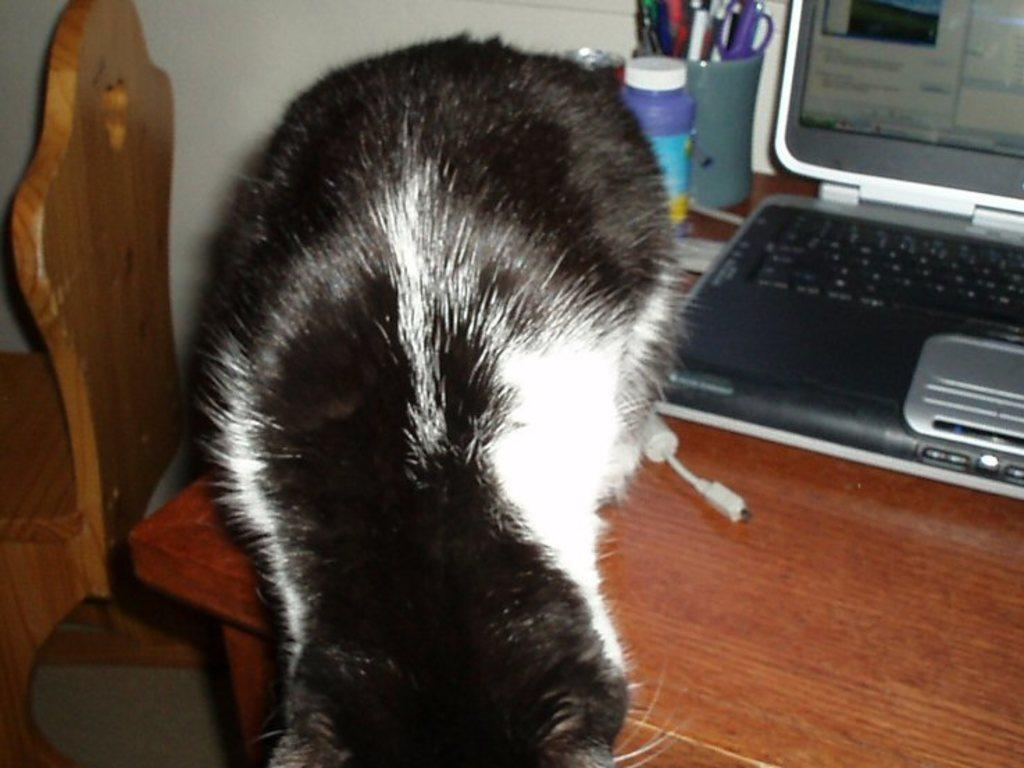What piece of furniture is present in the image? There is a chair in the image. What electronic device is on the table in the image? There is a laptop on a table in the image. What type of animal is on the table in the image? There is a cat on the table in the image. What type of container is in the image? There is a bottle in the image. What other objects can be seen on the table in the image? There are other objects on the table in the image. Can you see a chain attached to the cat in the image? There is no chain present in the image; the cat is on the table without any visible restraints. Is there a deer standing next to the chair in the image? There is no deer present in the image; the only animals mentioned are the cat on the table. 